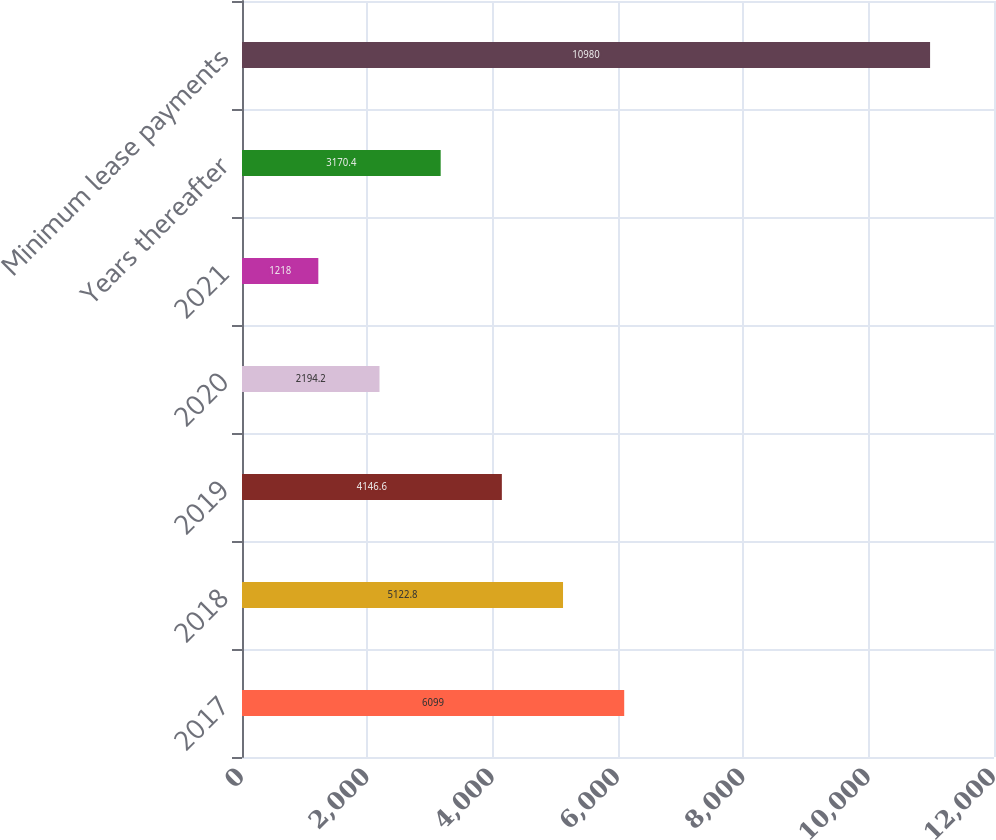Convert chart to OTSL. <chart><loc_0><loc_0><loc_500><loc_500><bar_chart><fcel>2017<fcel>2018<fcel>2019<fcel>2020<fcel>2021<fcel>Years thereafter<fcel>Minimum lease payments<nl><fcel>6099<fcel>5122.8<fcel>4146.6<fcel>2194.2<fcel>1218<fcel>3170.4<fcel>10980<nl></chart> 